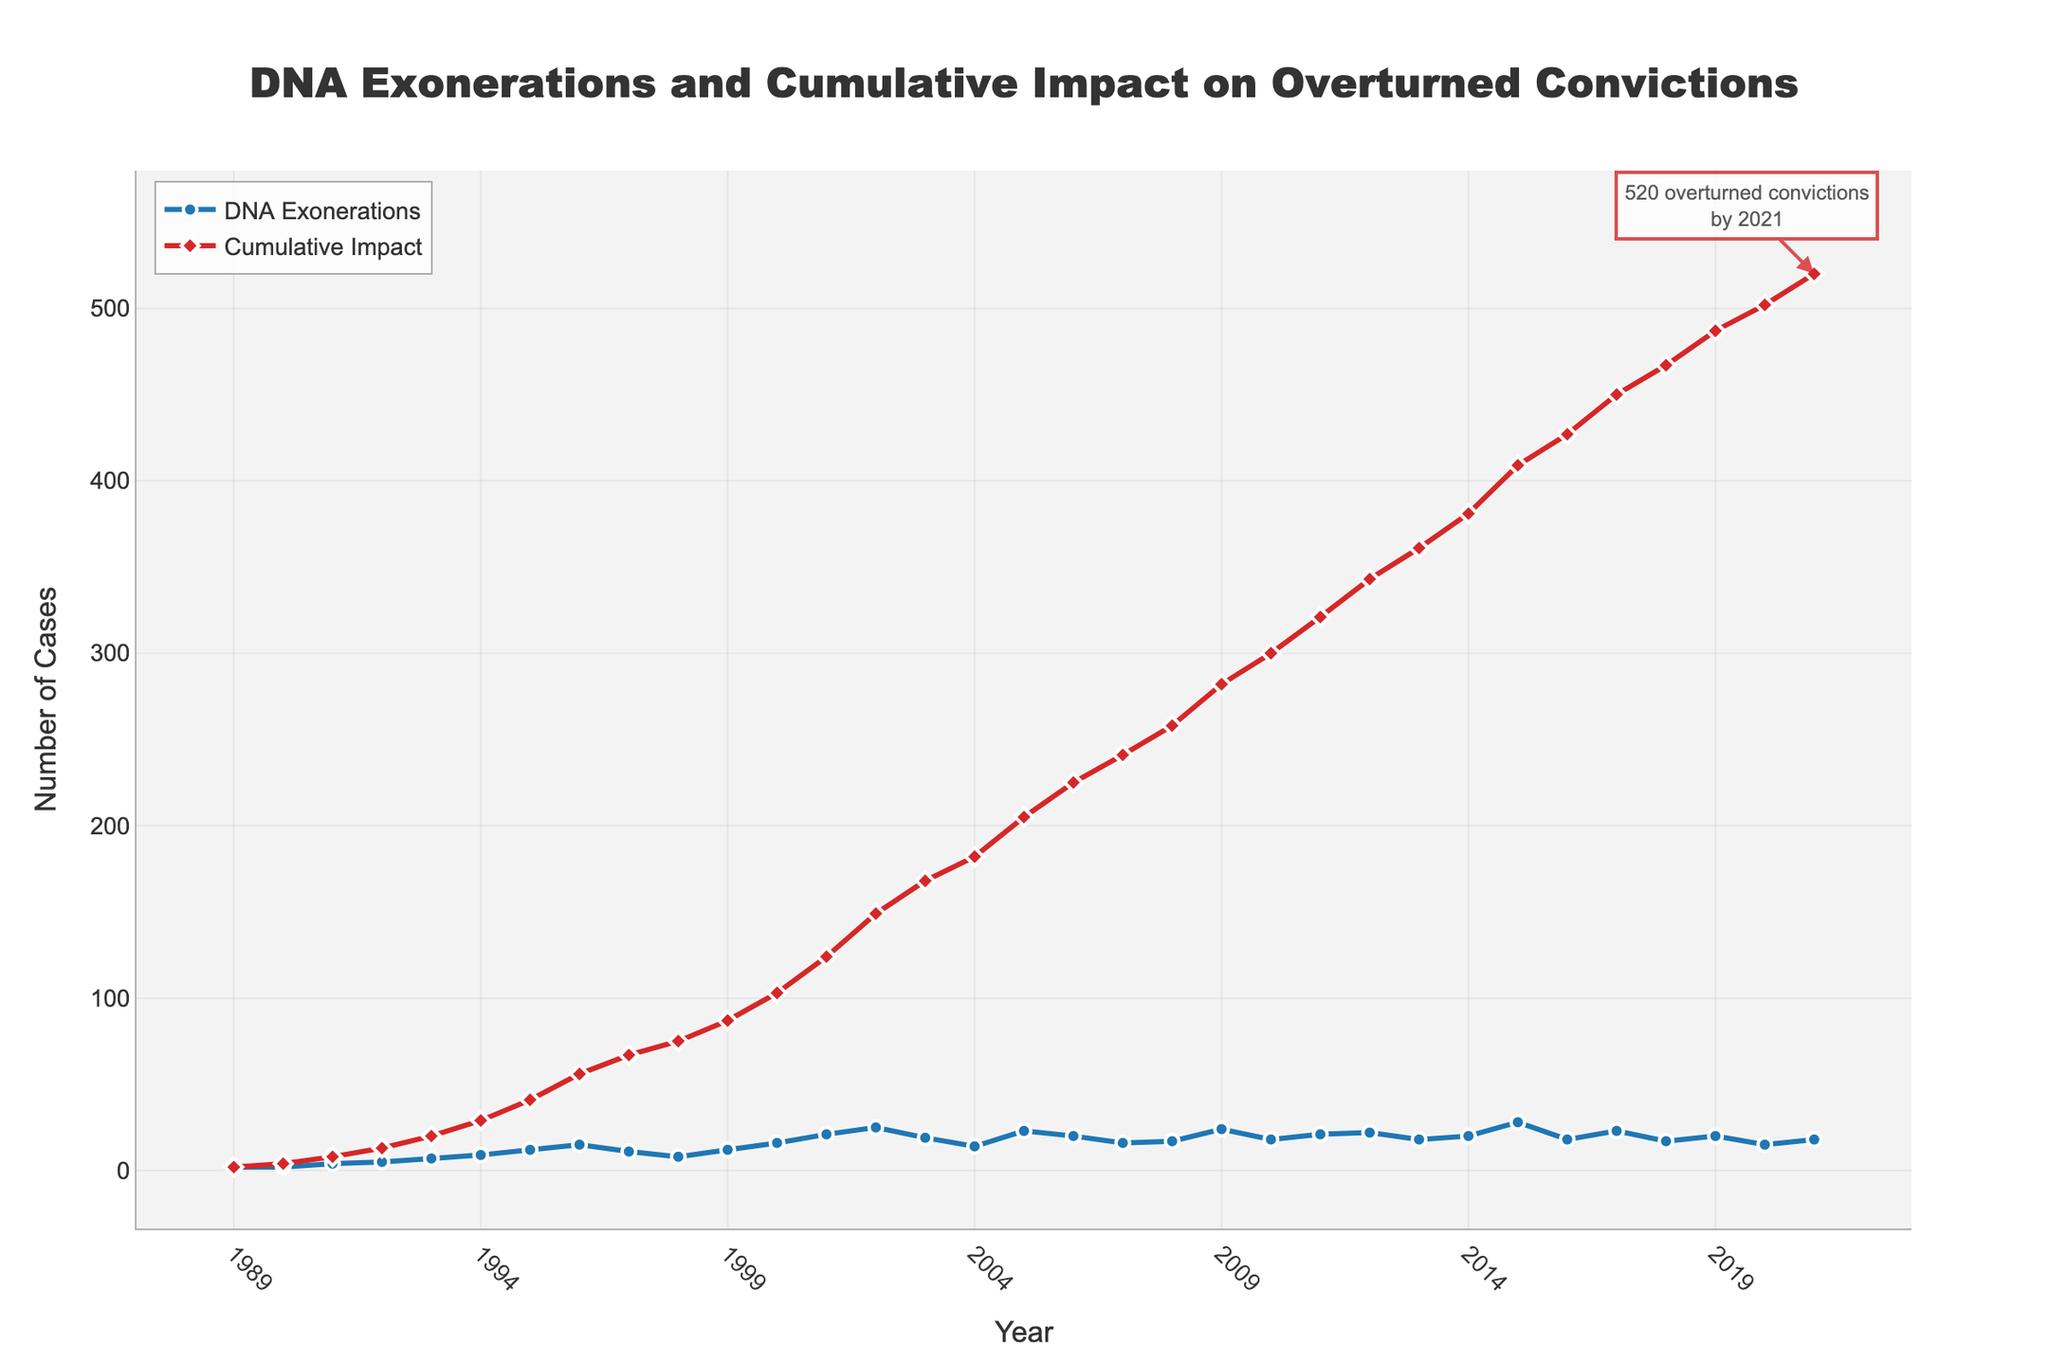How many DNA exonerations were there in 2001 and what was the cumulative impact on overturned convictions that year? In 2001, the number of DNA exonerations was 21. The cumulative impact on overturned convictions that year was 124.
Answer: 21 exonerations, 124 cumulative impact Between 2005 and 2010, which year had the most DNA exonerations? The years between 2005 and 2010 had the following DNA exonerations: 2005 (23), 2006 (20), 2007 (16), 2008 (17), 2009 (24), 2010 (18). The year with the most DNA exonerations was 2009.
Answer: 2009 What is the trend observed for the cumulative impact on overturned convictions from 1989 to 2021? From 1989 to 2021, the cumulative impact on overturned convictions shows a steady and consistent increase each year, indicating that the number of wrongful convictions overturned has been growing over time.
Answer: Steady increase Between 2012 and 2015, how much did the cumulative impact on overturned convictions increase? In 2012, the cumulative impact on overturned convictions was 343, and in 2015, it was 409. The increase between 2012 and 2015 is 409 - 343 = 66.
Answer: 66 Which color represents the cumulative impact on overturned convictions in the figure? The cumulative impact on overturned convictions is represented by the red line with diamond markers.
Answer: Red What was the highest number of DNA exonerations in a single year according to the figure, and in which year did it occur? The highest number of DNA exonerations in a single year according to the figure was 28, which occurred in 2015.
Answer: 28 in 2015 How many DNA exonerations occurred between 1990 and 1995? The number of DNA exonerations for each year from 1990 to 1995 is as follows: 1990 (2), 1991 (4), 1992 (5), 1993 (7), 1994 (9), 1995 (12). Summing these up gives: 2 + 4 + 5 + 7 + 9 + 12 = 39.
Answer: 39 What annotation is shown on the figure, and what information does it provide? The annotation on the figure is located at the point representing the year 2021 and provides information that 520 overturned convictions occurred by 2021.
Answer: 520 overturned convictions by 2021 Describe the pattern of DNA exonerations from 1989 to 1995. DNA exonerations started at 2 in 1989, remained at 2 in 1990, then progressively increased each year, reaching 12 by 1995. This indicates a gradual rise in the number of exonerations during this period.
Answer: Gradual rise 